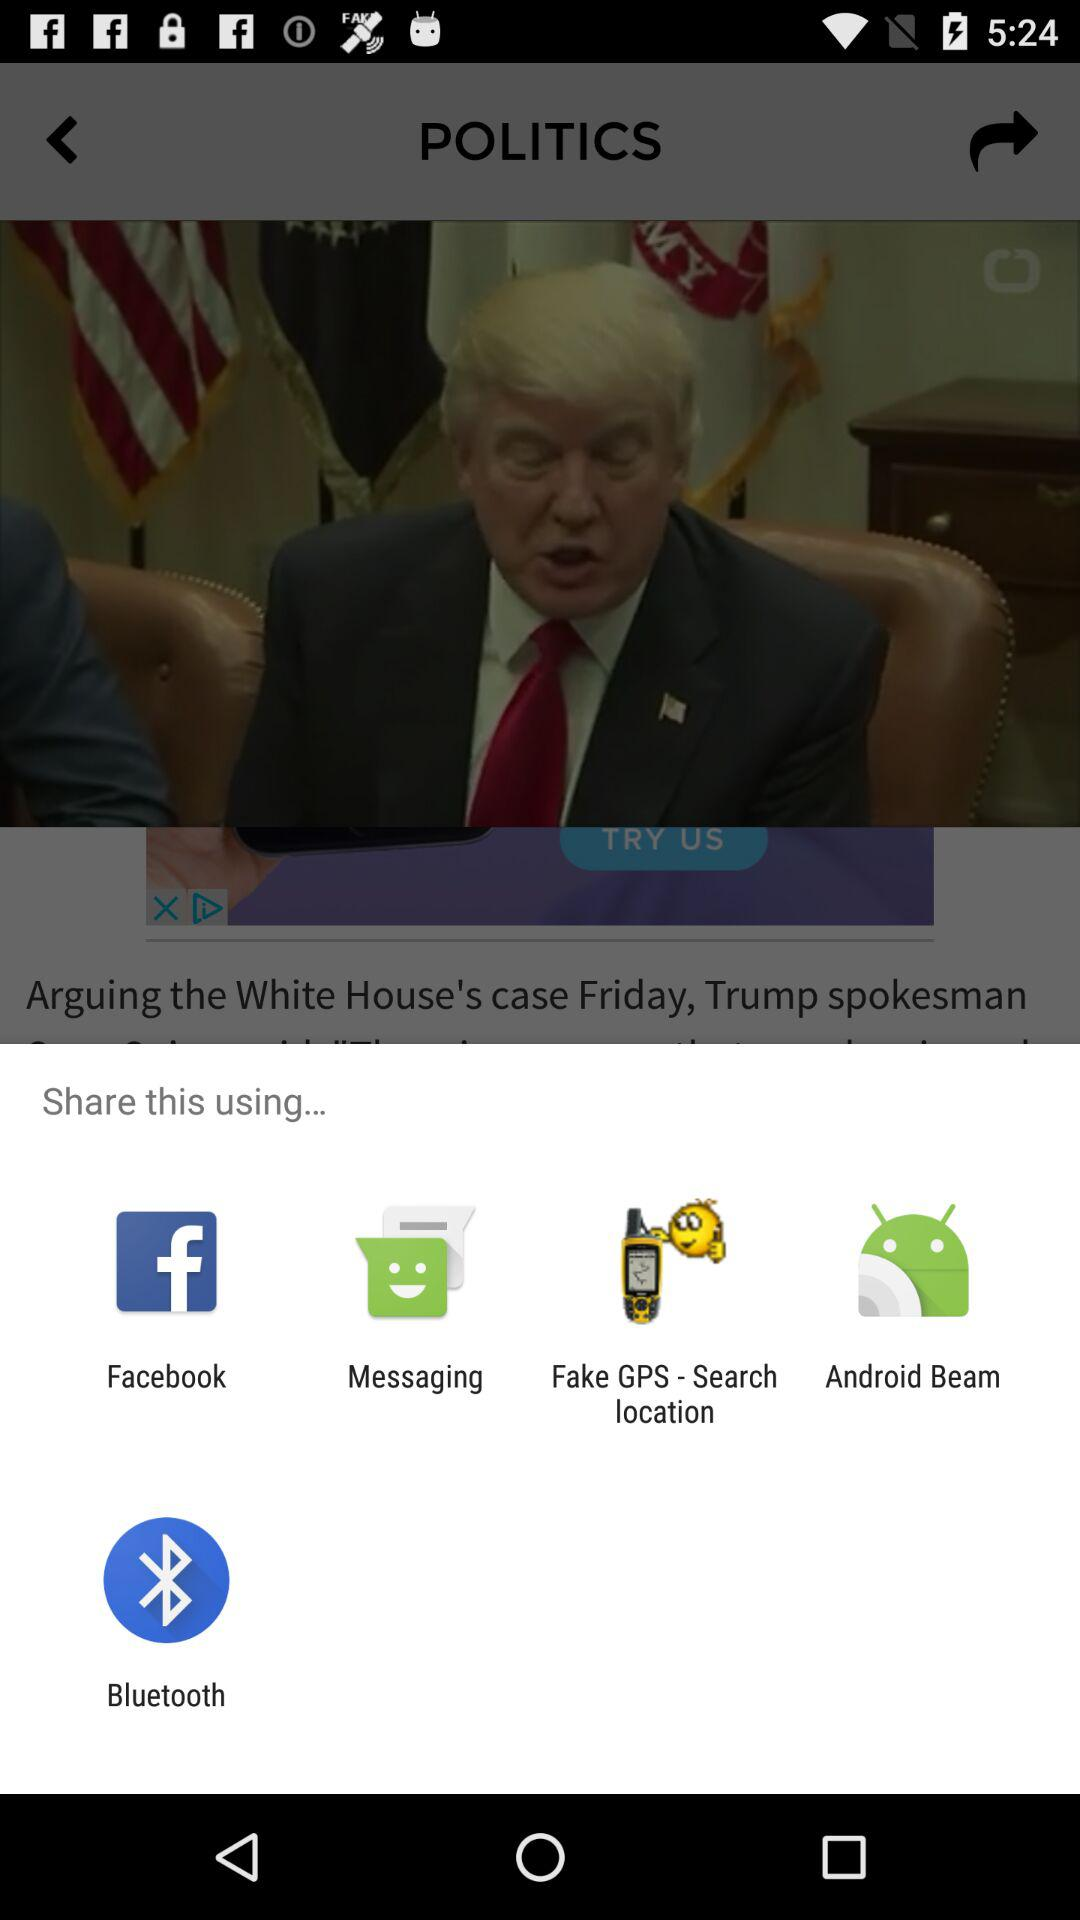What are the options to share? The options to share are "Facebook", "Messaging", "Fake GPS - Search location", "Android Beam" and "Bluetooth". 